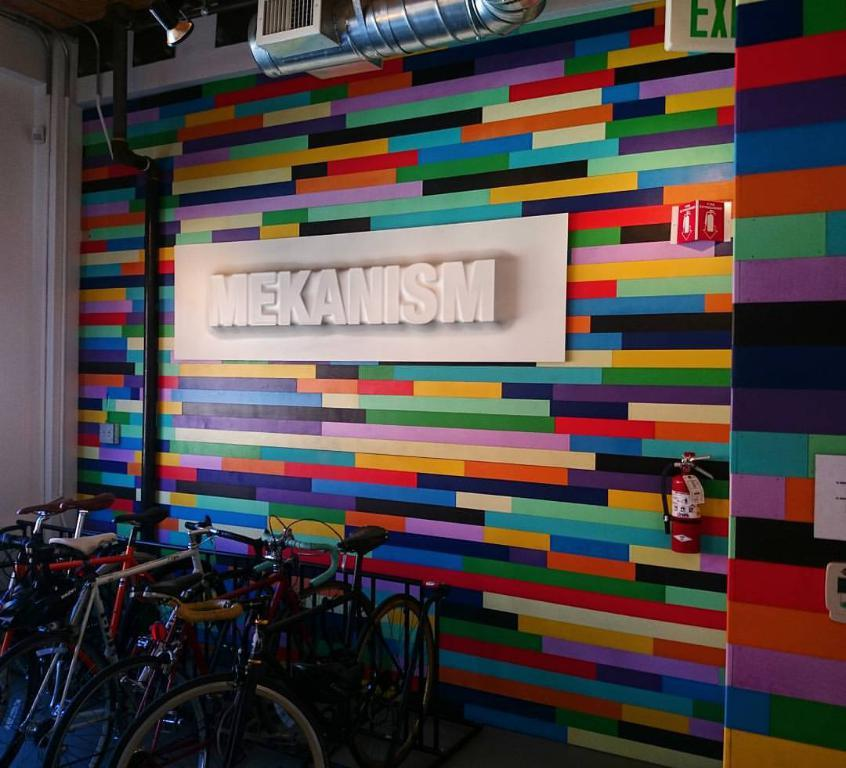Provide a one-sentence caption for the provided image. Bikes on the stand with a background of advertisement for brand " Mekanism". 